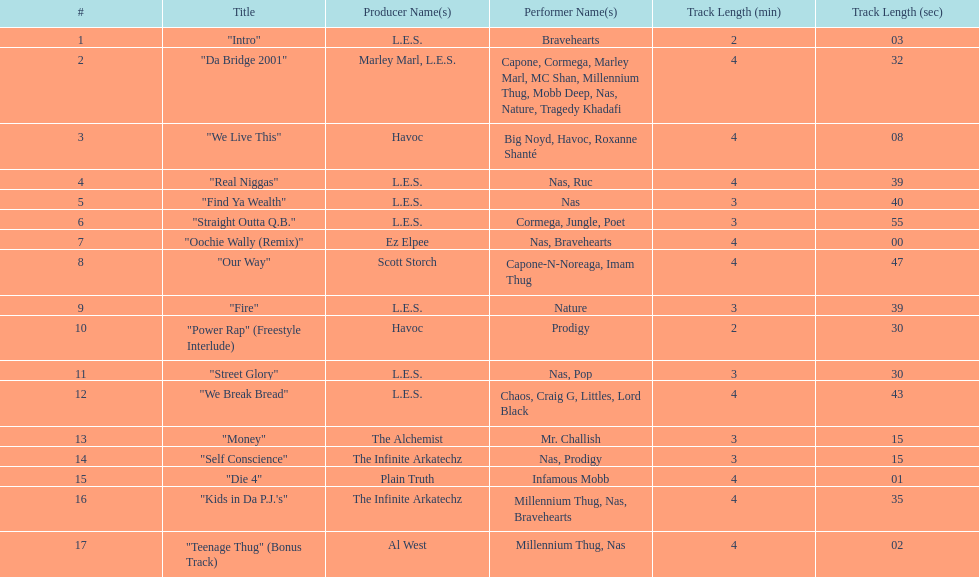After street glory, what song is listed? "We Break Bread". Give me the full table as a dictionary. {'header': ['#', 'Title', 'Producer Name(s)', 'Performer Name(s)', 'Track Length (min)', 'Track Length (sec)'], 'rows': [['1', '"Intro"', 'L.E.S.', 'Bravehearts', '2', '03'], ['2', '"Da Bridge 2001"', 'Marley Marl, L.E.S.', 'Capone, Cormega, Marley Marl, MC Shan, Millennium Thug, Mobb Deep, Nas, Nature, Tragedy Khadafi', '4', '32'], ['3', '"We Live This"', 'Havoc', 'Big Noyd, Havoc, Roxanne Shanté', '4', '08'], ['4', '"Real Niggas"', 'L.E.S.', 'Nas, Ruc', '4', '39'], ['5', '"Find Ya Wealth"', 'L.E.S.', 'Nas', '3', '40'], ['6', '"Straight Outta Q.B."', 'L.E.S.', 'Cormega, Jungle, Poet', '3', '55'], ['7', '"Oochie Wally (Remix)"', 'Ez Elpee', 'Nas, Bravehearts', '4', '00'], ['8', '"Our Way"', 'Scott Storch', 'Capone-N-Noreaga, Imam Thug', '4', '47'], ['9', '"Fire"', 'L.E.S.', 'Nature', '3', '39'], ['10', '"Power Rap" (Freestyle Interlude)', 'Havoc', 'Prodigy', '2', '30'], ['11', '"Street Glory"', 'L.E.S.', 'Nas, Pop', '3', '30'], ['12', '"We Break Bread"', 'L.E.S.', 'Chaos, Craig G, Littles, Lord Black', '4', '43'], ['13', '"Money"', 'The Alchemist', 'Mr. Challish', '3', '15'], ['14', '"Self Conscience"', 'The Infinite Arkatechz', 'Nas, Prodigy', '3', '15'], ['15', '"Die 4"', 'Plain Truth', 'Infamous Mobb', '4', '01'], ['16', '"Kids in Da P.J.\'s"', 'The Infinite Arkatechz', 'Millennium Thug, Nas, Bravehearts', '4', '35'], ['17', '"Teenage Thug" (Bonus Track)', 'Al West', 'Millennium Thug, Nas', '4', '02']]} 